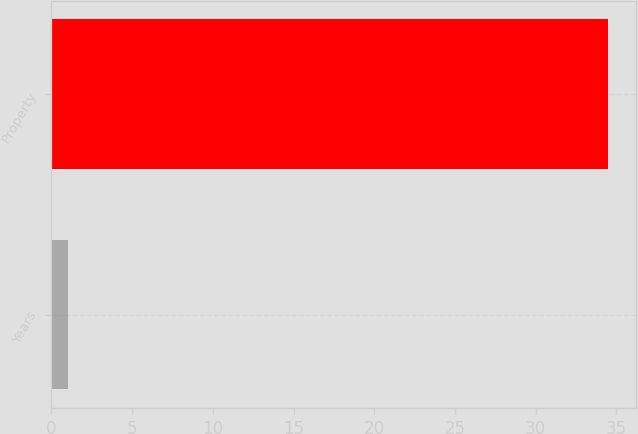Convert chart to OTSL. <chart><loc_0><loc_0><loc_500><loc_500><bar_chart><fcel>Years<fcel>Property<nl><fcel>1<fcel>34.5<nl></chart> 